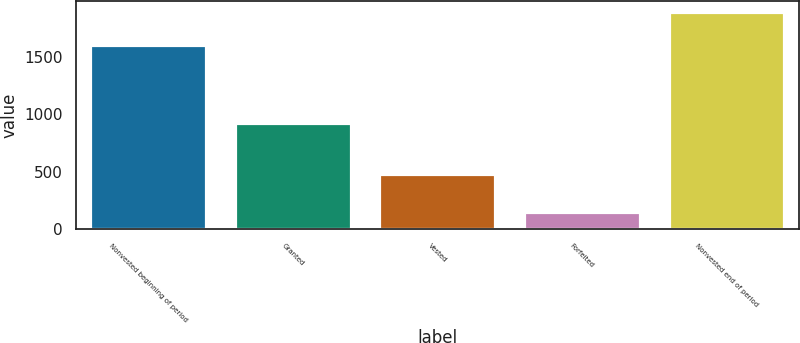<chart> <loc_0><loc_0><loc_500><loc_500><bar_chart><fcel>Nonvested beginning of period<fcel>Granted<fcel>Vested<fcel>Forfeited<fcel>Nonvested end of period<nl><fcel>1601<fcel>927<fcel>485<fcel>149<fcel>1894<nl></chart> 